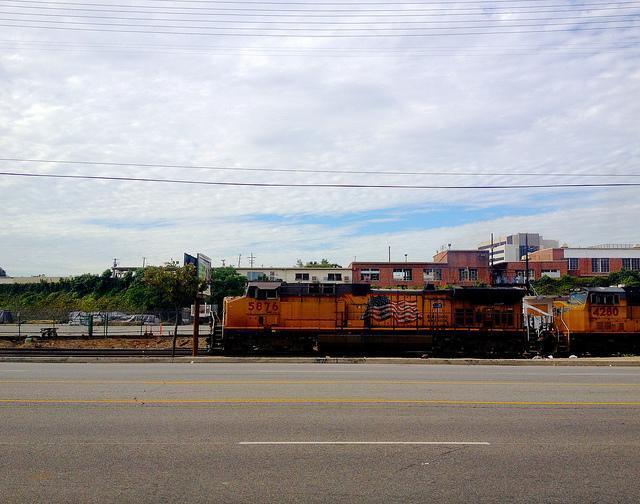How many men are wearing hats?
Give a very brief answer. 0. 